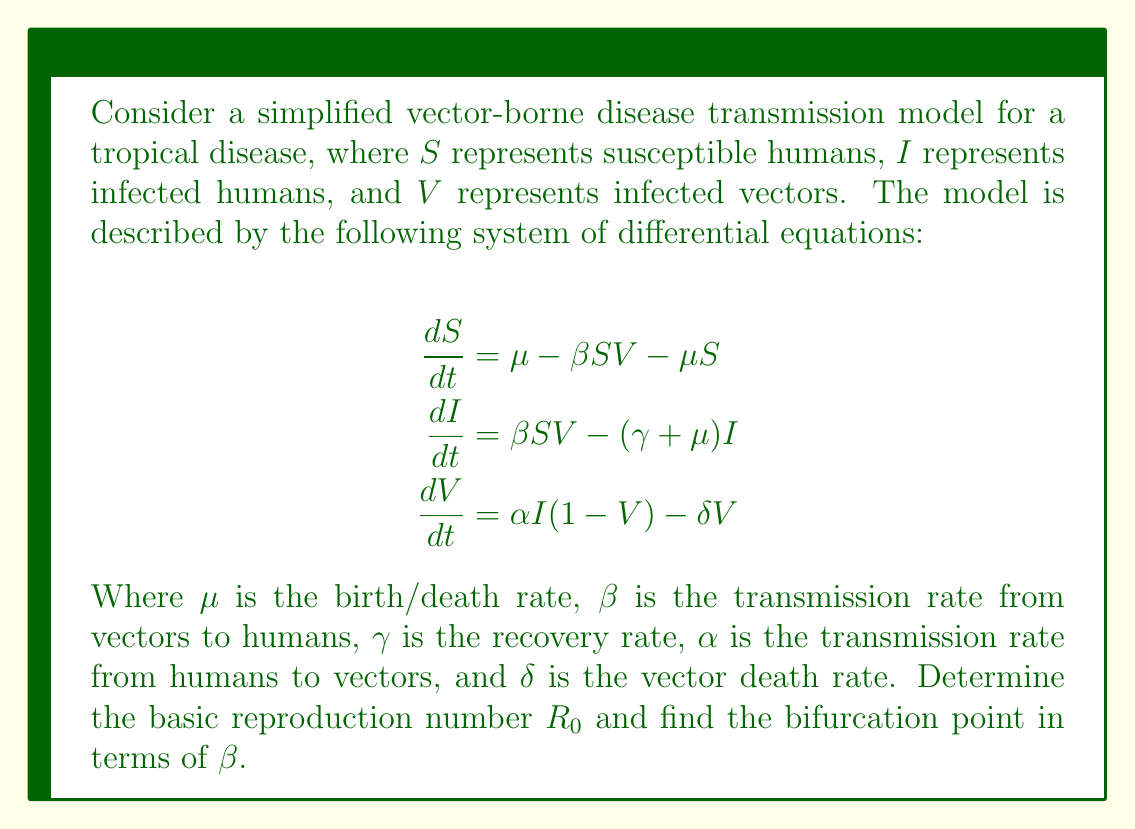Teach me how to tackle this problem. To solve this problem, we'll follow these steps:

1) First, we need to find the disease-free equilibrium (DFE). At DFE, $I=V=0$ and $S=1$ (assuming a normalized population).

2) Next, we'll use the next-generation matrix method to find $R_0$:

   a) Identify the infected compartments: $I$ and $V$
   b) Write the equations for new infections and transfers between compartments:
      $$\mathcal{F} = \begin{pmatrix} \beta SV \\ \alpha I(1-V) \end{pmatrix}, \quad 
        \mathcal{V} = \begin{pmatrix} (\gamma + \mu)I \\ \delta V \end{pmatrix}$$
   c) Calculate the Jacobian matrices of $\mathcal{F}$ and $\mathcal{V}$ at DFE:
      $$F = \begin{pmatrix} 0 & \beta \\ \alpha & 0 \end{pmatrix}, \quad
        V = \begin{pmatrix} \gamma + \mu & 0 \\ 0 & \delta \end{pmatrix}$$
   d) Calculate $FV^{-1}$:
      $$FV^{-1} = \begin{pmatrix} 0 & \beta \\ \alpha & 0 \end{pmatrix} 
                  \begin{pmatrix} \frac{1}{\gamma + \mu} & 0 \\ 0 & \frac{1}{\delta} \end{pmatrix}
                = \begin{pmatrix} 0 & \frac{\beta}{\delta} \\ \frac{\alpha}{\gamma + \mu} & 0 \end{pmatrix}$$
   e) $R_0$ is the spectral radius of $FV^{-1}$:
      $$R_0 = \sqrt{\frac{\alpha \beta}{(\gamma + \mu)\delta}}$$

3) The bifurcation point occurs when $R_0 = 1$. So we set:
   $$\sqrt{\frac{\alpha \beta}{(\gamma + \mu)\delta}} = 1$$

4) Solving for $\beta$:
   $$\frac{\alpha \beta}{(\gamma + \mu)\delta} = 1$$
   $$\beta = \frac{(\gamma + \mu)\delta}{\alpha}$$

This value of $\beta$ is the bifurcation point. When $\beta$ is less than this value, the disease-free equilibrium is stable. When $\beta$ exceeds this value, the endemic equilibrium becomes stable.
Answer: $\beta = \frac{(\gamma + \mu)\delta}{\alpha}$ 